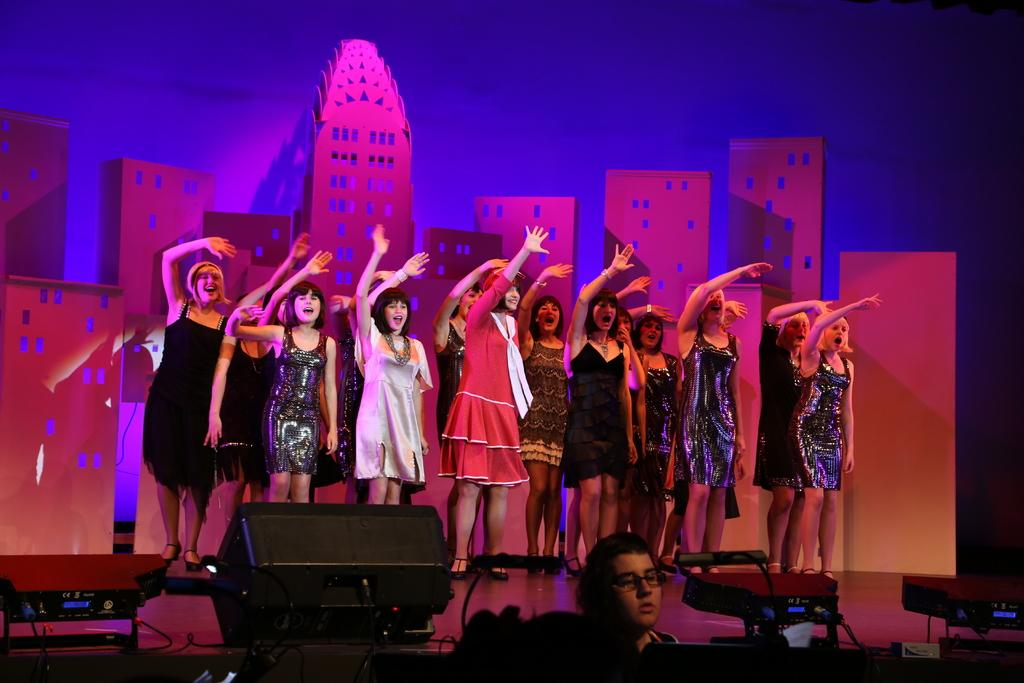What is happening in the image involving a group of people? The people in the image are dancing. What can be seen on the floor in the image? There are disco lights on the floor. What type of attention is the rat receiving from the dancing group in the image? There is no rat present in the image, so it cannot receive any attention from the dancing group. 